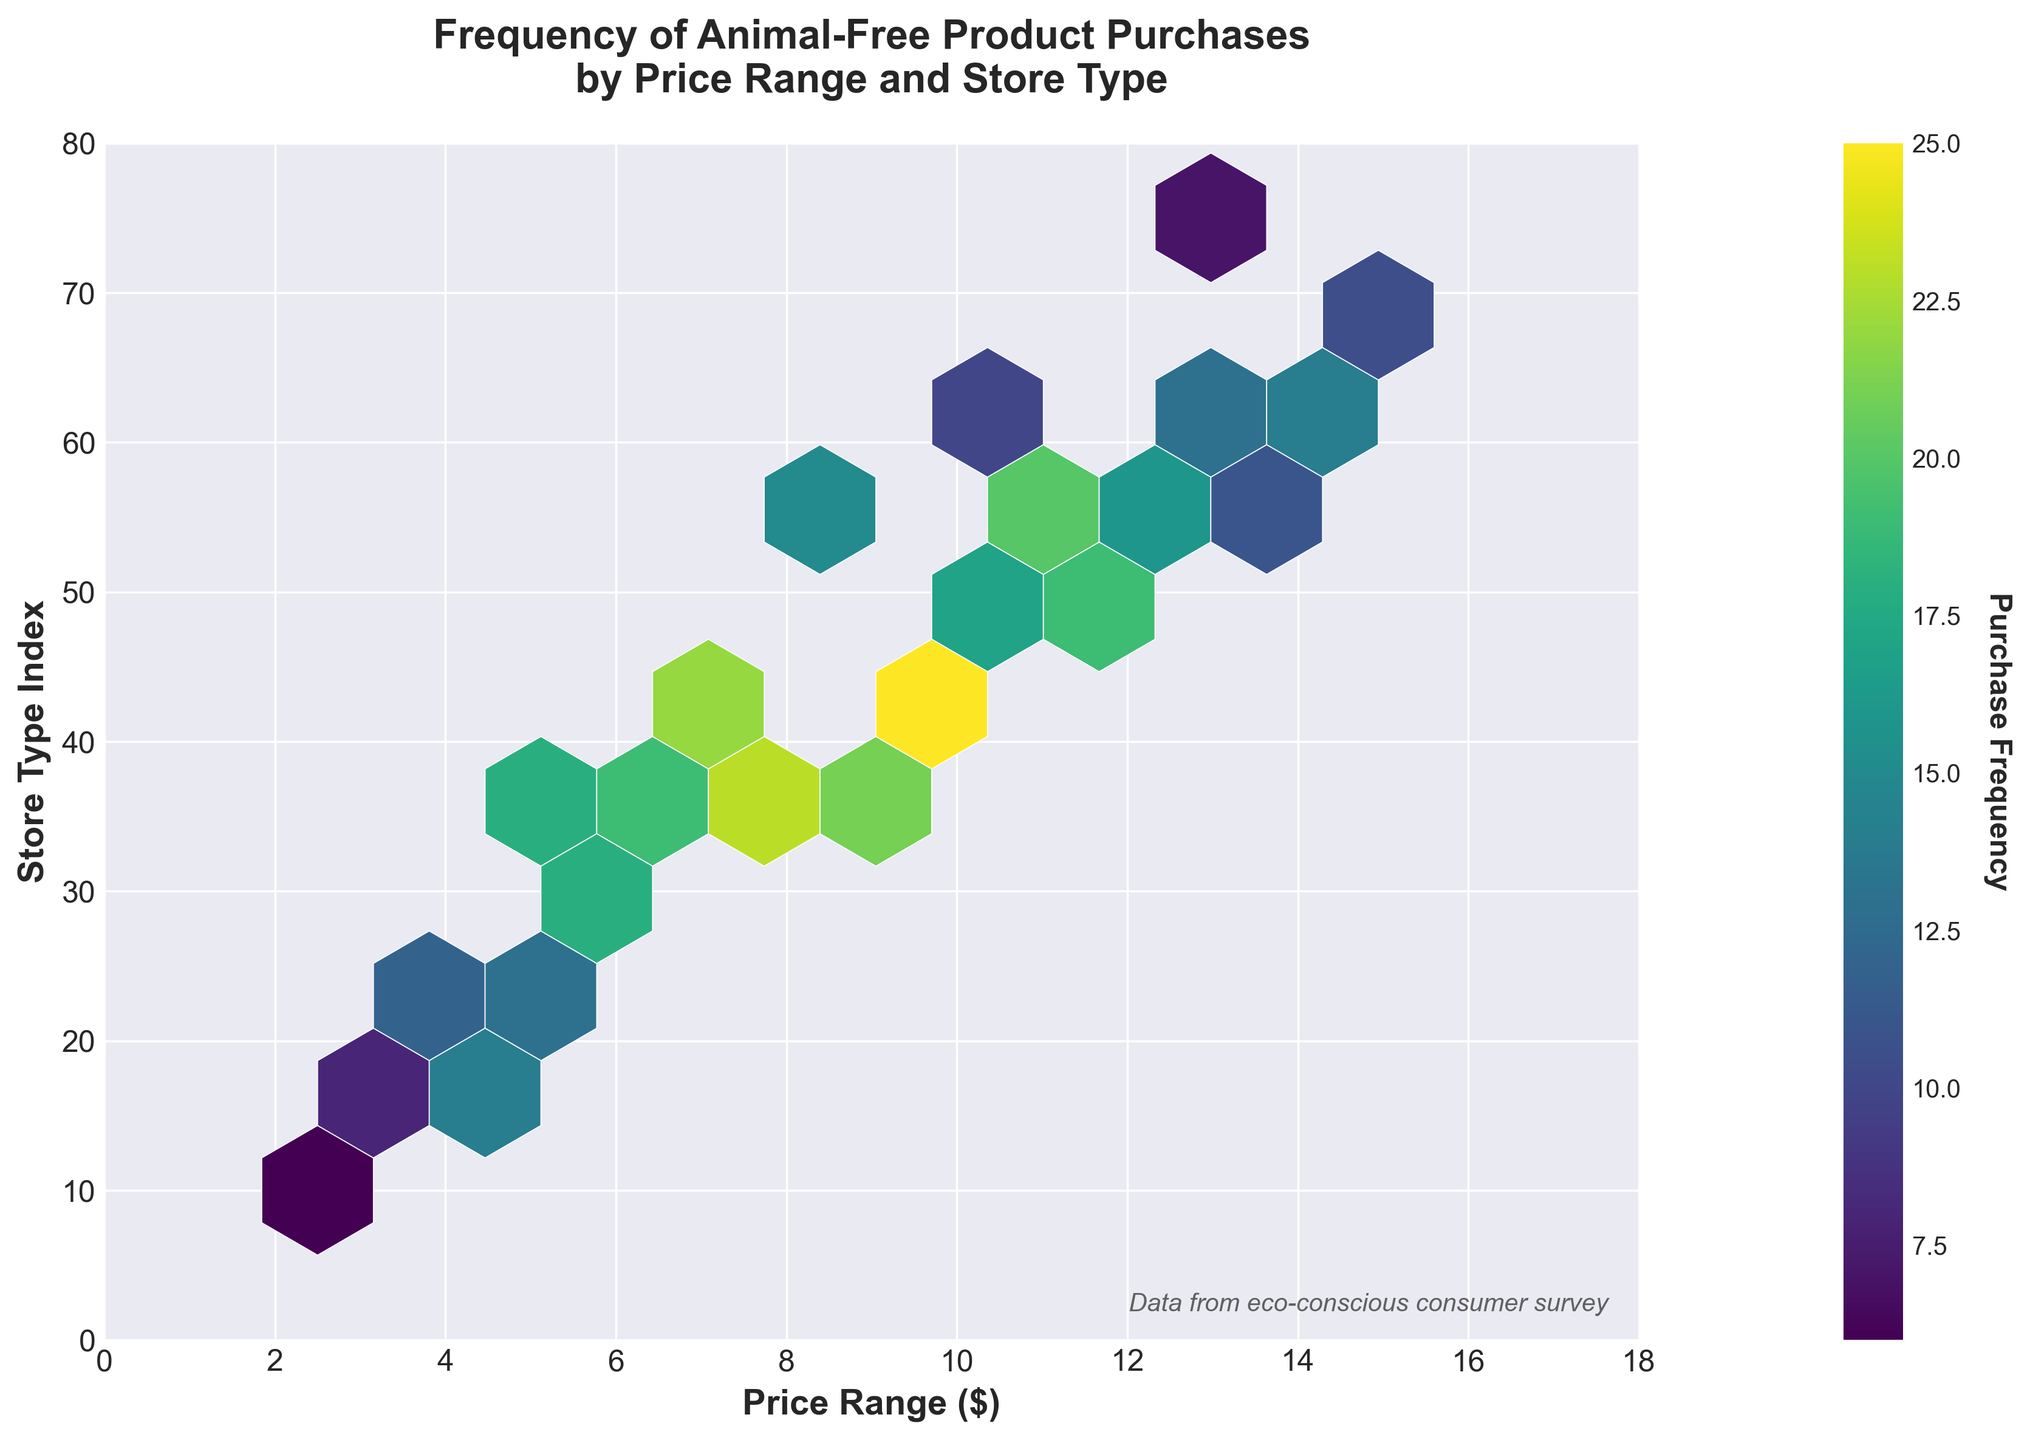What's the title of the figure? The title of the figure is located above the plot and typically provides a brief description of the data being visualized.
Answer: Frequency of Animal-Free Product Purchases by Price Range and Store Type What do the x and y axes represent? The labels on the x and y axes of the plot tell us what each axis represents. The x-axis label is "Price Range ($)" and the y-axis label is "Store Type Index".
Answer: Price Range ($) and Store Type Index What is the color of the area with the highest purchase frequency? The color of the hexagonal bin with the highest frequency can be identified by looking at the colorbar, which maps colors to frequency values. The color corresponding to the highest value on the colorbar is a shade of yellow.
Answer: Yellow In which price range and store type combination was the highest frequency observed? By examining the hexagonal bins and referencing the colorbar, we can identify that the highest frequency is around the coordinate (9.2, 43) on the plot.
Answer: Around (9.2, 43) Which price range has the highest average purchase frequency? To find this, review each column (vertical arrangement of points), sum the frequencies, and divide by the number of bins in the column. Performing this manually might require some detailed work, but the price range around 9.2 to 9.8 seems to feature high points frequently, hinting at a higher average.
Answer: Around $9.2-$9.8 Are there any price ranges and store types where the purchase frequency is zero? We need to check if there are any hexagonal bins that are absent (no color) on the plot within the plot limits (0-18 for Price and 0-80 for Store Type).
Answer: No, there are no zero-frequency bins within the plotted area Which store type index shows a peak in purchases? We can identify the peak by spotting the highest frequency bin on the y-axis. The peaks is at the store type index around 43.
Answer: Around 43 How does purchase frequency change as the price range increases? Generally, following the distribution pattern across the x-axis, we can see that higher frequency bins are more common between lower and mid-price ranges ($5 to $10) tapering off as prices increase beyond $14.
Answer: Decreases with higher prices Is there a significant purchase frequency for very high price ranges (above $15)? Examine the bins to the right of the price range above $15 on the x-axis. Observations show low frequencies in this range, confirming that purchases are less common at higher prices.
Answer: No For store types with a high index (above 60), in which price range does the highest purchase frequency occur? Check the hexagonal bins that are higher on the y-axis (above 60) and spot the bins within that range. The price range around $14.8 shows the highest frequency.
Answer: Around $14.8 